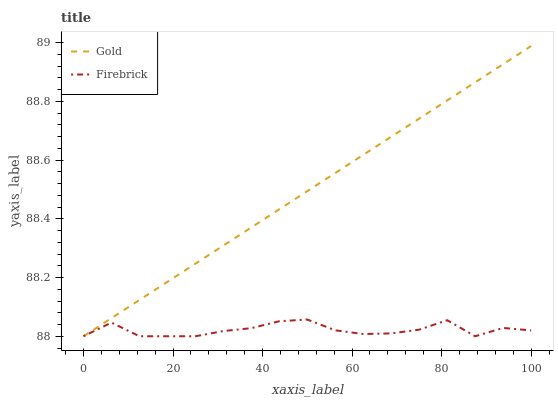Does Gold have the minimum area under the curve?
Answer yes or no. No. Is Gold the roughest?
Answer yes or no. No. 